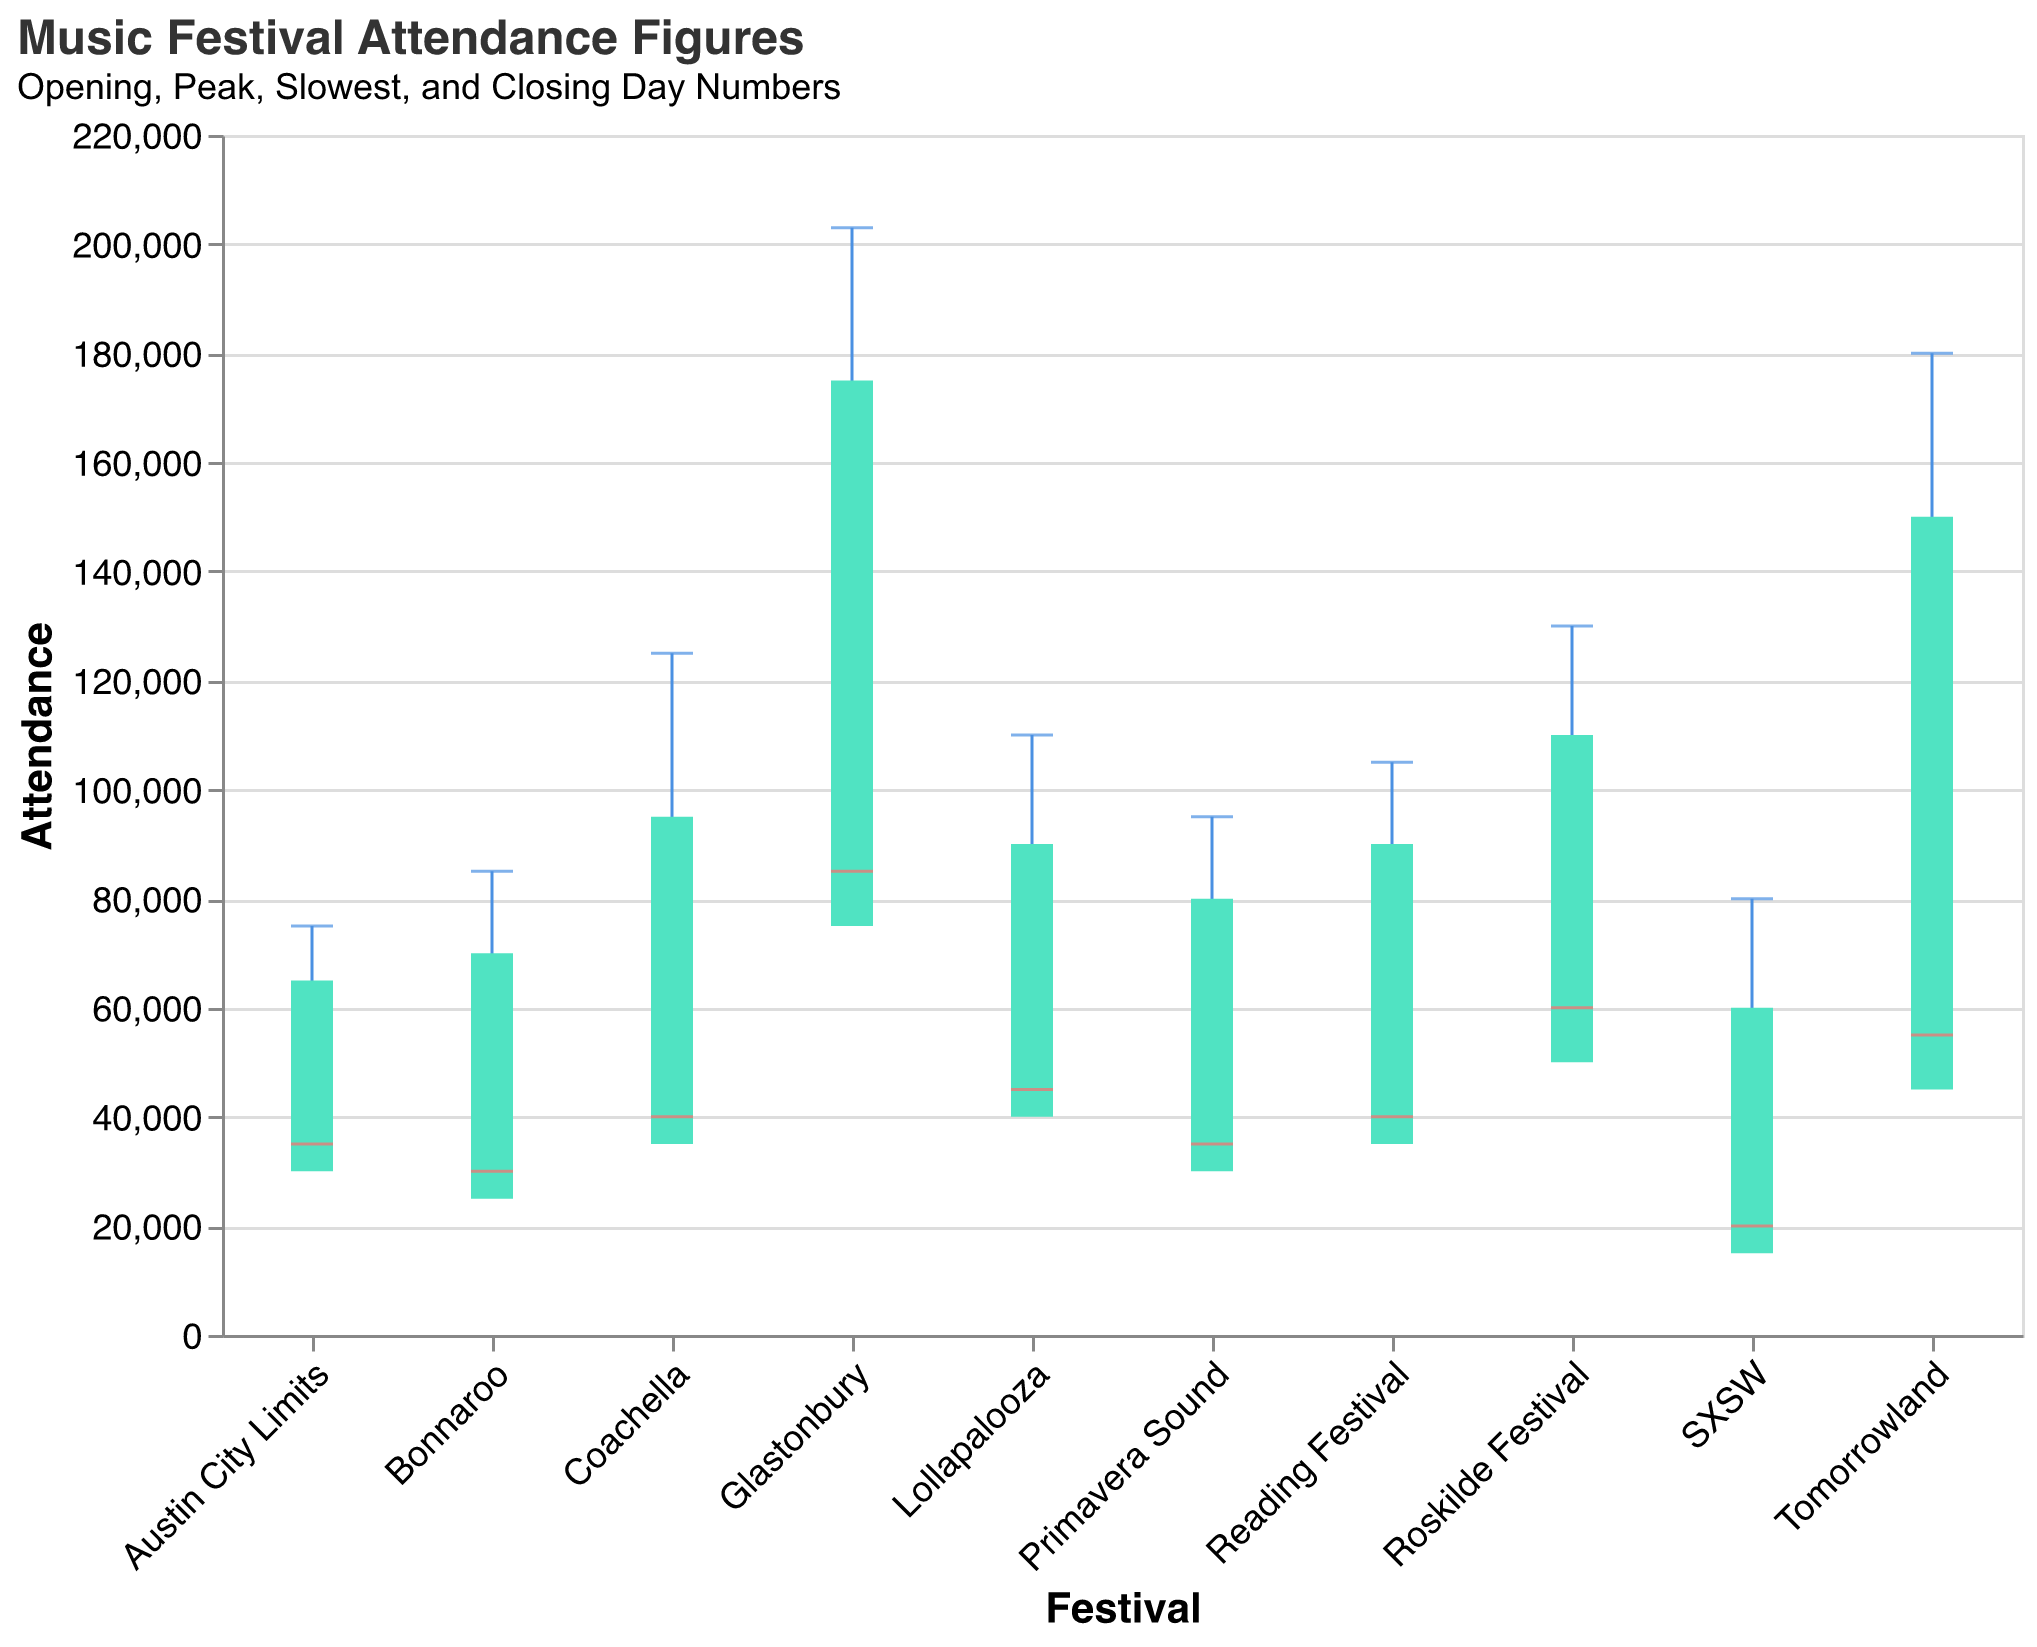What is the highest peak day attendance among the festivals? By looking at the peak day values indicated by the highest vertical points on the "rule" markers, Glastonbury has the highest peak day attendance at 203,000.
Answer: 203,000 Which festival has the lowest opening day attendance? By identifying the lowest opening day marker within the bar section, SXSW has the lowest opening day attendance at 15,000.
Answer: 15,000 How does the attendance on the slowest day of Tomorrowland compare to the slowest day of Coachella? The slowest day attendance for Tomorrowland is 55,000 and for Coachella, it is 40,000. Comparing these two, Tomorrowland's slowest day attendance is higher by 15,000.
Answer: 15,000 What is the difference between the closing day attendance of Bonnaroo and Austin City Limits? Bonnaroo has a closing day attendance of 70,000 while Austin City Limits has 65,000. The difference is 70,000 - 65,000 = 5,000.
Answer: 5,000 Which festival has the smallest range between its peak day and slowest day attendance? To find the smallest range: (Peak Day - Slowest Day) for each festival and compare. For example, for SXSW it's 80,000 - 20,000 = 60,000. After comparing all, Austin City Limits has the smallest range of 75,000 - 35,000 = 40,000.
Answer: 40,000 Identify the festival with the most balanced attendance (i.e., minimal difference between the opening day and closing day). By observing the heights of the bars and looking for the smallest difference between the opening and closing days, Roskilde Festival has the most balanced attendance with 50,000 on opening day and 110,000 on closing day making the difference 110,000 - 50,000 = 60,000.
Answer: 60,000 Which two festivals show the greatest increase in attendance from opening day to peak day? Analyze the vertical span of the "rule" markers from opening to peak day. Glastonbury shows an increase from 75,000 to 203,000 and Tomorrowland from 45,000 to 180,000. Comparing these, Glastonbury has the greatest increase: 203,000 - 75,000 = 128,000.
Answer: 128,000 